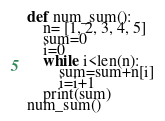<code> <loc_0><loc_0><loc_500><loc_500><_Python_>def num_sum():
	n= [1, 2, 3, 4, 5]
	sum=0
	i=0
	while i<len(n):
		sum=sum+n[i]
		i=i+1
	print(sum)
num_sum()</code> 